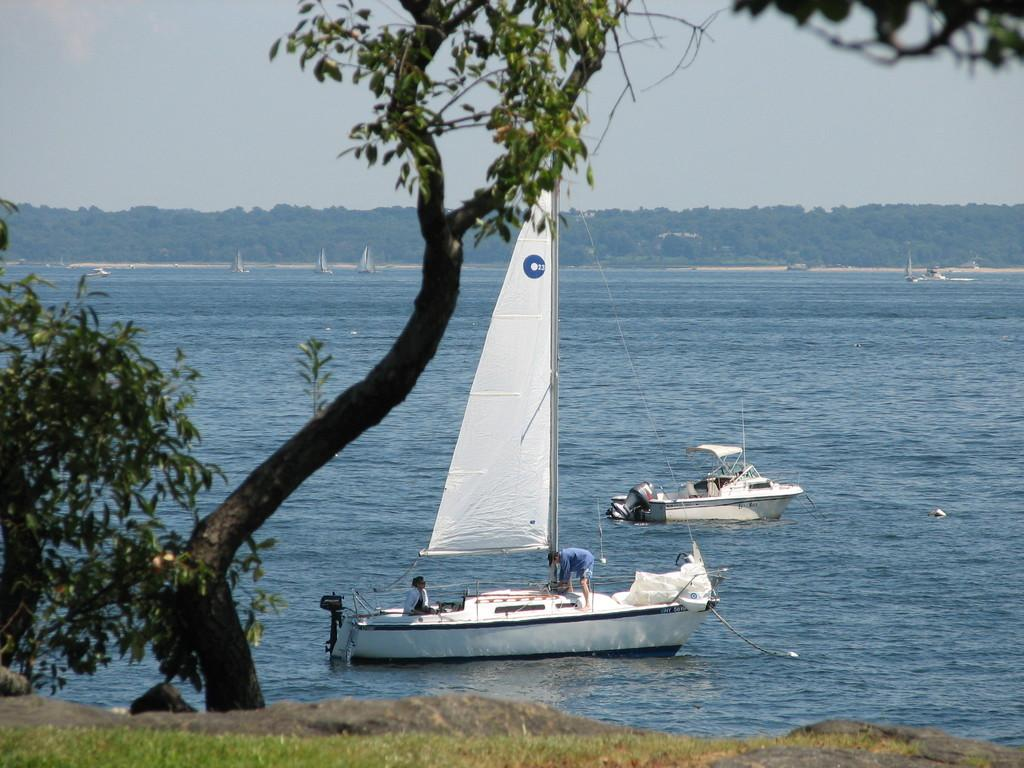What is the main subject of the image? The main subject of the image is boats on a water body. Are there any people in the image? Yes, there are people on the boats in the image. What can be seen in the foreground of the image? There is a tree in the foreground of the image. What is visible in the background of the image? In the background of the image, there are trees, a building, and the sky. What type of toys can be seen in the hands of the people on the boats? There are no toys visible in the image; the people on the boats are not holding any toys. 